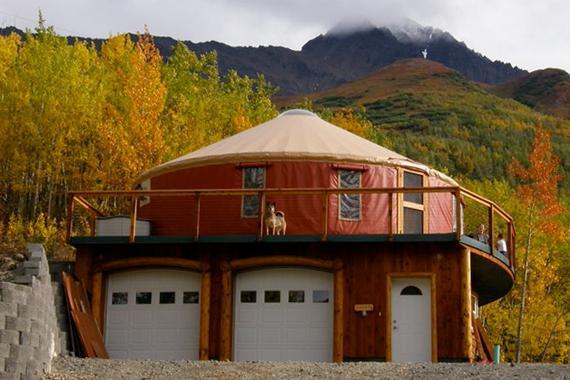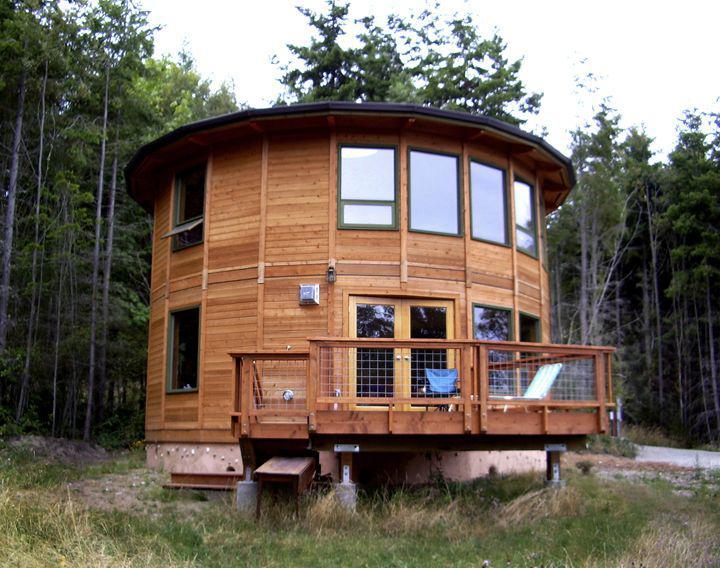The first image is the image on the left, the second image is the image on the right. Evaluate the accuracy of this statement regarding the images: "An image shows a round house with a railing above two white garage doors.". Is it true? Answer yes or no. Yes. The first image is the image on the left, the second image is the image on the right. Considering the images on both sides, is "Each of two yurts has two distinct levels and one or more fenced wooden deck sections." valid? Answer yes or no. Yes. 